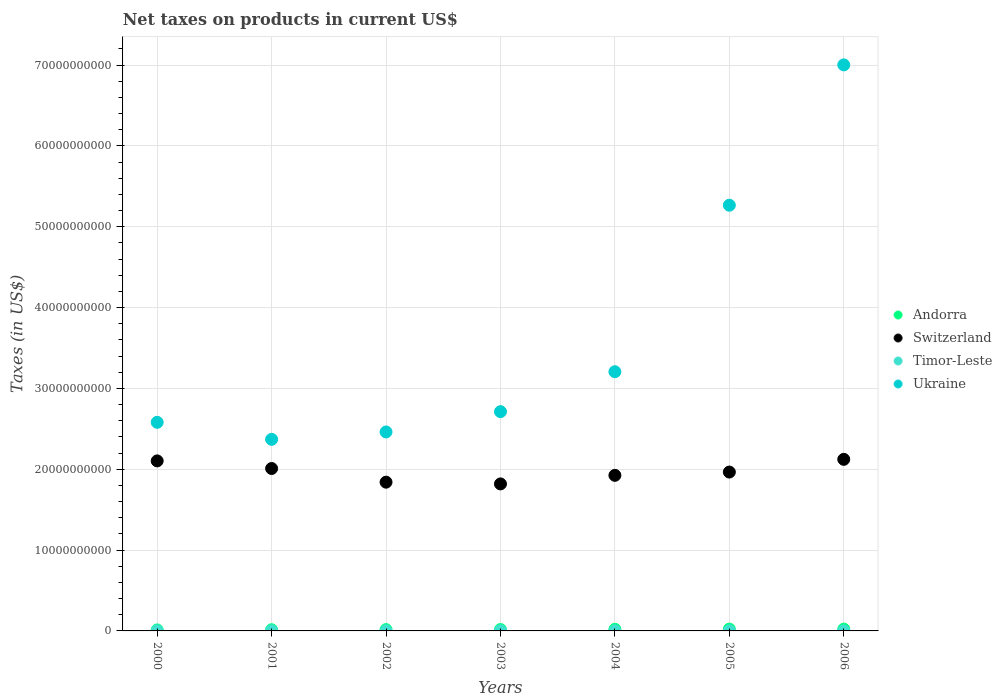How many different coloured dotlines are there?
Ensure brevity in your answer.  4. What is the net taxes on products in Ukraine in 2001?
Give a very brief answer. 2.37e+1. Across all years, what is the maximum net taxes on products in Ukraine?
Your answer should be compact. 7.00e+1. Across all years, what is the minimum net taxes on products in Switzerland?
Your answer should be compact. 1.82e+1. What is the total net taxes on products in Timor-Leste in the graph?
Provide a short and direct response. 6.80e+07. What is the difference between the net taxes on products in Ukraine in 2003 and the net taxes on products in Andorra in 2005?
Offer a very short reply. 2.69e+1. What is the average net taxes on products in Timor-Leste per year?
Offer a terse response. 9.71e+06. In the year 2002, what is the difference between the net taxes on products in Ukraine and net taxes on products in Timor-Leste?
Ensure brevity in your answer.  2.46e+1. What is the ratio of the net taxes on products in Timor-Leste in 2000 to that in 2005?
Ensure brevity in your answer.  0.42. What is the difference between the highest and the second highest net taxes on products in Switzerland?
Give a very brief answer. 1.93e+08. What is the difference between the highest and the lowest net taxes on products in Timor-Leste?
Your answer should be very brief. 1.60e+07. Is the sum of the net taxes on products in Ukraine in 2003 and 2004 greater than the maximum net taxes on products in Andorra across all years?
Make the answer very short. Yes. Is it the case that in every year, the sum of the net taxes on products in Ukraine and net taxes on products in Andorra  is greater than the sum of net taxes on products in Switzerland and net taxes on products in Timor-Leste?
Make the answer very short. Yes. Is it the case that in every year, the sum of the net taxes on products in Andorra and net taxes on products in Ukraine  is greater than the net taxes on products in Timor-Leste?
Your answer should be compact. Yes. Does the net taxes on products in Andorra monotonically increase over the years?
Offer a very short reply. No. Is the net taxes on products in Ukraine strictly greater than the net taxes on products in Switzerland over the years?
Ensure brevity in your answer.  Yes. How many dotlines are there?
Provide a succinct answer. 4. Does the graph contain any zero values?
Your answer should be very brief. Yes. Where does the legend appear in the graph?
Offer a terse response. Center right. What is the title of the graph?
Your response must be concise. Net taxes on products in current US$. Does "Switzerland" appear as one of the legend labels in the graph?
Your answer should be very brief. Yes. What is the label or title of the Y-axis?
Keep it short and to the point. Taxes (in US$). What is the Taxes (in US$) in Andorra in 2000?
Provide a succinct answer. 1.24e+08. What is the Taxes (in US$) of Switzerland in 2000?
Keep it short and to the point. 2.10e+1. What is the Taxes (in US$) in Timor-Leste in 2000?
Provide a short and direct response. 5.00e+06. What is the Taxes (in US$) of Ukraine in 2000?
Provide a succinct answer. 2.58e+1. What is the Taxes (in US$) in Andorra in 2001?
Your answer should be very brief. 1.47e+08. What is the Taxes (in US$) of Switzerland in 2001?
Give a very brief answer. 2.01e+1. What is the Taxes (in US$) in Timor-Leste in 2001?
Offer a very short reply. 8.00e+06. What is the Taxes (in US$) of Ukraine in 2001?
Offer a terse response. 2.37e+1. What is the Taxes (in US$) of Andorra in 2002?
Offer a very short reply. 1.66e+08. What is the Taxes (in US$) of Switzerland in 2002?
Ensure brevity in your answer.  1.84e+1. What is the Taxes (in US$) of Timor-Leste in 2002?
Provide a succinct answer. 1.20e+07. What is the Taxes (in US$) in Ukraine in 2002?
Your response must be concise. 2.46e+1. What is the Taxes (in US$) of Andorra in 2003?
Give a very brief answer. 1.74e+08. What is the Taxes (in US$) of Switzerland in 2003?
Your answer should be compact. 1.82e+1. What is the Taxes (in US$) of Timor-Leste in 2003?
Make the answer very short. 1.50e+07. What is the Taxes (in US$) in Ukraine in 2003?
Provide a short and direct response. 2.71e+1. What is the Taxes (in US$) in Andorra in 2004?
Your answer should be compact. 2.00e+08. What is the Taxes (in US$) in Switzerland in 2004?
Make the answer very short. 1.92e+1. What is the Taxes (in US$) of Timor-Leste in 2004?
Offer a very short reply. 1.60e+07. What is the Taxes (in US$) in Ukraine in 2004?
Make the answer very short. 3.21e+1. What is the Taxes (in US$) in Andorra in 2005?
Give a very brief answer. 2.24e+08. What is the Taxes (in US$) in Switzerland in 2005?
Offer a terse response. 1.97e+1. What is the Taxes (in US$) in Ukraine in 2005?
Provide a succinct answer. 5.27e+1. What is the Taxes (in US$) of Andorra in 2006?
Offer a very short reply. 2.23e+08. What is the Taxes (in US$) of Switzerland in 2006?
Your answer should be compact. 2.12e+1. What is the Taxes (in US$) of Ukraine in 2006?
Keep it short and to the point. 7.00e+1. Across all years, what is the maximum Taxes (in US$) of Andorra?
Offer a very short reply. 2.24e+08. Across all years, what is the maximum Taxes (in US$) in Switzerland?
Your response must be concise. 2.12e+1. Across all years, what is the maximum Taxes (in US$) in Timor-Leste?
Ensure brevity in your answer.  1.60e+07. Across all years, what is the maximum Taxes (in US$) in Ukraine?
Provide a succinct answer. 7.00e+1. Across all years, what is the minimum Taxes (in US$) of Andorra?
Provide a succinct answer. 1.24e+08. Across all years, what is the minimum Taxes (in US$) in Switzerland?
Ensure brevity in your answer.  1.82e+1. Across all years, what is the minimum Taxes (in US$) in Ukraine?
Offer a terse response. 2.37e+1. What is the total Taxes (in US$) in Andorra in the graph?
Give a very brief answer. 1.26e+09. What is the total Taxes (in US$) of Switzerland in the graph?
Offer a very short reply. 1.38e+11. What is the total Taxes (in US$) in Timor-Leste in the graph?
Provide a short and direct response. 6.80e+07. What is the total Taxes (in US$) of Ukraine in the graph?
Ensure brevity in your answer.  2.56e+11. What is the difference between the Taxes (in US$) in Andorra in 2000 and that in 2001?
Your answer should be compact. -2.25e+07. What is the difference between the Taxes (in US$) in Switzerland in 2000 and that in 2001?
Provide a short and direct response. 9.39e+08. What is the difference between the Taxes (in US$) in Timor-Leste in 2000 and that in 2001?
Offer a terse response. -3.00e+06. What is the difference between the Taxes (in US$) in Ukraine in 2000 and that in 2001?
Make the answer very short. 2.11e+09. What is the difference between the Taxes (in US$) of Andorra in 2000 and that in 2002?
Your response must be concise. -4.13e+07. What is the difference between the Taxes (in US$) of Switzerland in 2000 and that in 2002?
Provide a short and direct response. 2.63e+09. What is the difference between the Taxes (in US$) of Timor-Leste in 2000 and that in 2002?
Offer a very short reply. -7.00e+06. What is the difference between the Taxes (in US$) in Ukraine in 2000 and that in 2002?
Offer a terse response. 1.19e+09. What is the difference between the Taxes (in US$) of Andorra in 2000 and that in 2003?
Keep it short and to the point. -4.95e+07. What is the difference between the Taxes (in US$) in Switzerland in 2000 and that in 2003?
Ensure brevity in your answer.  2.85e+09. What is the difference between the Taxes (in US$) of Timor-Leste in 2000 and that in 2003?
Offer a terse response. -1.00e+07. What is the difference between the Taxes (in US$) in Ukraine in 2000 and that in 2003?
Your response must be concise. -1.32e+09. What is the difference between the Taxes (in US$) in Andorra in 2000 and that in 2004?
Keep it short and to the point. -7.55e+07. What is the difference between the Taxes (in US$) of Switzerland in 2000 and that in 2004?
Provide a short and direct response. 1.79e+09. What is the difference between the Taxes (in US$) of Timor-Leste in 2000 and that in 2004?
Your answer should be compact. -1.10e+07. What is the difference between the Taxes (in US$) of Ukraine in 2000 and that in 2004?
Keep it short and to the point. -6.26e+09. What is the difference between the Taxes (in US$) in Andorra in 2000 and that in 2005?
Ensure brevity in your answer.  -9.97e+07. What is the difference between the Taxes (in US$) of Switzerland in 2000 and that in 2005?
Provide a succinct answer. 1.38e+09. What is the difference between the Taxes (in US$) in Timor-Leste in 2000 and that in 2005?
Give a very brief answer. -7.00e+06. What is the difference between the Taxes (in US$) of Ukraine in 2000 and that in 2005?
Provide a short and direct response. -2.69e+1. What is the difference between the Taxes (in US$) of Andorra in 2000 and that in 2006?
Your answer should be compact. -9.82e+07. What is the difference between the Taxes (in US$) of Switzerland in 2000 and that in 2006?
Your answer should be compact. -1.93e+08. What is the difference between the Taxes (in US$) of Ukraine in 2000 and that in 2006?
Keep it short and to the point. -4.42e+1. What is the difference between the Taxes (in US$) in Andorra in 2001 and that in 2002?
Keep it short and to the point. -1.88e+07. What is the difference between the Taxes (in US$) of Switzerland in 2001 and that in 2002?
Your response must be concise. 1.69e+09. What is the difference between the Taxes (in US$) of Ukraine in 2001 and that in 2002?
Offer a terse response. -9.16e+08. What is the difference between the Taxes (in US$) of Andorra in 2001 and that in 2003?
Your response must be concise. -2.70e+07. What is the difference between the Taxes (in US$) in Switzerland in 2001 and that in 2003?
Offer a very short reply. 1.91e+09. What is the difference between the Taxes (in US$) in Timor-Leste in 2001 and that in 2003?
Provide a short and direct response. -7.00e+06. What is the difference between the Taxes (in US$) of Ukraine in 2001 and that in 2003?
Your response must be concise. -3.43e+09. What is the difference between the Taxes (in US$) of Andorra in 2001 and that in 2004?
Keep it short and to the point. -5.30e+07. What is the difference between the Taxes (in US$) in Switzerland in 2001 and that in 2004?
Offer a terse response. 8.47e+08. What is the difference between the Taxes (in US$) of Timor-Leste in 2001 and that in 2004?
Your answer should be compact. -8.00e+06. What is the difference between the Taxes (in US$) in Ukraine in 2001 and that in 2004?
Keep it short and to the point. -8.37e+09. What is the difference between the Taxes (in US$) of Andorra in 2001 and that in 2005?
Your answer should be very brief. -7.72e+07. What is the difference between the Taxes (in US$) of Switzerland in 2001 and that in 2005?
Offer a very short reply. 4.40e+08. What is the difference between the Taxes (in US$) of Ukraine in 2001 and that in 2005?
Your answer should be compact. -2.90e+1. What is the difference between the Taxes (in US$) of Andorra in 2001 and that in 2006?
Your answer should be compact. -7.58e+07. What is the difference between the Taxes (in US$) of Switzerland in 2001 and that in 2006?
Your answer should be compact. -1.13e+09. What is the difference between the Taxes (in US$) of Ukraine in 2001 and that in 2006?
Offer a terse response. -4.63e+1. What is the difference between the Taxes (in US$) in Andorra in 2002 and that in 2003?
Ensure brevity in your answer.  -8.15e+06. What is the difference between the Taxes (in US$) in Switzerland in 2002 and that in 2003?
Make the answer very short. 2.15e+08. What is the difference between the Taxes (in US$) of Timor-Leste in 2002 and that in 2003?
Provide a short and direct response. -3.00e+06. What is the difference between the Taxes (in US$) in Ukraine in 2002 and that in 2003?
Ensure brevity in your answer.  -2.51e+09. What is the difference between the Taxes (in US$) of Andorra in 2002 and that in 2004?
Ensure brevity in your answer.  -3.42e+07. What is the difference between the Taxes (in US$) in Switzerland in 2002 and that in 2004?
Your answer should be very brief. -8.44e+08. What is the difference between the Taxes (in US$) of Timor-Leste in 2002 and that in 2004?
Provide a short and direct response. -4.00e+06. What is the difference between the Taxes (in US$) in Ukraine in 2002 and that in 2004?
Your response must be concise. -7.45e+09. What is the difference between the Taxes (in US$) of Andorra in 2002 and that in 2005?
Your answer should be very brief. -5.84e+07. What is the difference between the Taxes (in US$) in Switzerland in 2002 and that in 2005?
Provide a succinct answer. -1.25e+09. What is the difference between the Taxes (in US$) in Ukraine in 2002 and that in 2005?
Give a very brief answer. -2.81e+1. What is the difference between the Taxes (in US$) of Andorra in 2002 and that in 2006?
Offer a terse response. -5.69e+07. What is the difference between the Taxes (in US$) of Switzerland in 2002 and that in 2006?
Ensure brevity in your answer.  -2.82e+09. What is the difference between the Taxes (in US$) of Ukraine in 2002 and that in 2006?
Your answer should be compact. -4.54e+1. What is the difference between the Taxes (in US$) in Andorra in 2003 and that in 2004?
Ensure brevity in your answer.  -2.60e+07. What is the difference between the Taxes (in US$) in Switzerland in 2003 and that in 2004?
Your response must be concise. -1.06e+09. What is the difference between the Taxes (in US$) in Ukraine in 2003 and that in 2004?
Give a very brief answer. -4.94e+09. What is the difference between the Taxes (in US$) of Andorra in 2003 and that in 2005?
Provide a short and direct response. -5.02e+07. What is the difference between the Taxes (in US$) of Switzerland in 2003 and that in 2005?
Your answer should be very brief. -1.47e+09. What is the difference between the Taxes (in US$) in Timor-Leste in 2003 and that in 2005?
Provide a succinct answer. 3.00e+06. What is the difference between the Taxes (in US$) in Ukraine in 2003 and that in 2005?
Make the answer very short. -2.55e+1. What is the difference between the Taxes (in US$) in Andorra in 2003 and that in 2006?
Keep it short and to the point. -4.88e+07. What is the difference between the Taxes (in US$) in Switzerland in 2003 and that in 2006?
Your response must be concise. -3.04e+09. What is the difference between the Taxes (in US$) in Ukraine in 2003 and that in 2006?
Your answer should be compact. -4.29e+1. What is the difference between the Taxes (in US$) in Andorra in 2004 and that in 2005?
Your answer should be compact. -2.42e+07. What is the difference between the Taxes (in US$) in Switzerland in 2004 and that in 2005?
Provide a succinct answer. -4.07e+08. What is the difference between the Taxes (in US$) in Timor-Leste in 2004 and that in 2005?
Offer a very short reply. 4.00e+06. What is the difference between the Taxes (in US$) of Ukraine in 2004 and that in 2005?
Offer a very short reply. -2.06e+1. What is the difference between the Taxes (in US$) of Andorra in 2004 and that in 2006?
Offer a terse response. -2.28e+07. What is the difference between the Taxes (in US$) of Switzerland in 2004 and that in 2006?
Offer a terse response. -1.98e+09. What is the difference between the Taxes (in US$) of Ukraine in 2004 and that in 2006?
Ensure brevity in your answer.  -3.80e+1. What is the difference between the Taxes (in US$) in Andorra in 2005 and that in 2006?
Offer a very short reply. 1.46e+06. What is the difference between the Taxes (in US$) in Switzerland in 2005 and that in 2006?
Your answer should be compact. -1.57e+09. What is the difference between the Taxes (in US$) of Ukraine in 2005 and that in 2006?
Ensure brevity in your answer.  -1.74e+1. What is the difference between the Taxes (in US$) of Andorra in 2000 and the Taxes (in US$) of Switzerland in 2001?
Ensure brevity in your answer.  -2.00e+1. What is the difference between the Taxes (in US$) in Andorra in 2000 and the Taxes (in US$) in Timor-Leste in 2001?
Provide a succinct answer. 1.16e+08. What is the difference between the Taxes (in US$) in Andorra in 2000 and the Taxes (in US$) in Ukraine in 2001?
Your answer should be very brief. -2.36e+1. What is the difference between the Taxes (in US$) in Switzerland in 2000 and the Taxes (in US$) in Timor-Leste in 2001?
Keep it short and to the point. 2.10e+1. What is the difference between the Taxes (in US$) of Switzerland in 2000 and the Taxes (in US$) of Ukraine in 2001?
Your answer should be compact. -2.67e+09. What is the difference between the Taxes (in US$) of Timor-Leste in 2000 and the Taxes (in US$) of Ukraine in 2001?
Ensure brevity in your answer.  -2.37e+1. What is the difference between the Taxes (in US$) in Andorra in 2000 and the Taxes (in US$) in Switzerland in 2002?
Your response must be concise. -1.83e+1. What is the difference between the Taxes (in US$) in Andorra in 2000 and the Taxes (in US$) in Timor-Leste in 2002?
Make the answer very short. 1.12e+08. What is the difference between the Taxes (in US$) in Andorra in 2000 and the Taxes (in US$) in Ukraine in 2002?
Offer a very short reply. -2.45e+1. What is the difference between the Taxes (in US$) in Switzerland in 2000 and the Taxes (in US$) in Timor-Leste in 2002?
Your answer should be compact. 2.10e+1. What is the difference between the Taxes (in US$) in Switzerland in 2000 and the Taxes (in US$) in Ukraine in 2002?
Offer a very short reply. -3.58e+09. What is the difference between the Taxes (in US$) in Timor-Leste in 2000 and the Taxes (in US$) in Ukraine in 2002?
Make the answer very short. -2.46e+1. What is the difference between the Taxes (in US$) in Andorra in 2000 and the Taxes (in US$) in Switzerland in 2003?
Your answer should be very brief. -1.81e+1. What is the difference between the Taxes (in US$) in Andorra in 2000 and the Taxes (in US$) in Timor-Leste in 2003?
Offer a terse response. 1.09e+08. What is the difference between the Taxes (in US$) of Andorra in 2000 and the Taxes (in US$) of Ukraine in 2003?
Keep it short and to the point. -2.70e+1. What is the difference between the Taxes (in US$) of Switzerland in 2000 and the Taxes (in US$) of Timor-Leste in 2003?
Keep it short and to the point. 2.10e+1. What is the difference between the Taxes (in US$) in Switzerland in 2000 and the Taxes (in US$) in Ukraine in 2003?
Your response must be concise. -6.09e+09. What is the difference between the Taxes (in US$) in Timor-Leste in 2000 and the Taxes (in US$) in Ukraine in 2003?
Your answer should be very brief. -2.71e+1. What is the difference between the Taxes (in US$) in Andorra in 2000 and the Taxes (in US$) in Switzerland in 2004?
Your response must be concise. -1.91e+1. What is the difference between the Taxes (in US$) in Andorra in 2000 and the Taxes (in US$) in Timor-Leste in 2004?
Your answer should be compact. 1.08e+08. What is the difference between the Taxes (in US$) of Andorra in 2000 and the Taxes (in US$) of Ukraine in 2004?
Provide a succinct answer. -3.19e+1. What is the difference between the Taxes (in US$) in Switzerland in 2000 and the Taxes (in US$) in Timor-Leste in 2004?
Offer a terse response. 2.10e+1. What is the difference between the Taxes (in US$) of Switzerland in 2000 and the Taxes (in US$) of Ukraine in 2004?
Your response must be concise. -1.10e+1. What is the difference between the Taxes (in US$) in Timor-Leste in 2000 and the Taxes (in US$) in Ukraine in 2004?
Offer a terse response. -3.21e+1. What is the difference between the Taxes (in US$) in Andorra in 2000 and the Taxes (in US$) in Switzerland in 2005?
Your response must be concise. -1.95e+1. What is the difference between the Taxes (in US$) of Andorra in 2000 and the Taxes (in US$) of Timor-Leste in 2005?
Ensure brevity in your answer.  1.12e+08. What is the difference between the Taxes (in US$) of Andorra in 2000 and the Taxes (in US$) of Ukraine in 2005?
Your response must be concise. -5.25e+1. What is the difference between the Taxes (in US$) in Switzerland in 2000 and the Taxes (in US$) in Timor-Leste in 2005?
Your response must be concise. 2.10e+1. What is the difference between the Taxes (in US$) in Switzerland in 2000 and the Taxes (in US$) in Ukraine in 2005?
Offer a very short reply. -3.16e+1. What is the difference between the Taxes (in US$) of Timor-Leste in 2000 and the Taxes (in US$) of Ukraine in 2005?
Ensure brevity in your answer.  -5.27e+1. What is the difference between the Taxes (in US$) in Andorra in 2000 and the Taxes (in US$) in Switzerland in 2006?
Give a very brief answer. -2.11e+1. What is the difference between the Taxes (in US$) in Andorra in 2000 and the Taxes (in US$) in Ukraine in 2006?
Offer a terse response. -6.99e+1. What is the difference between the Taxes (in US$) in Switzerland in 2000 and the Taxes (in US$) in Ukraine in 2006?
Offer a very short reply. -4.90e+1. What is the difference between the Taxes (in US$) of Timor-Leste in 2000 and the Taxes (in US$) of Ukraine in 2006?
Your answer should be compact. -7.00e+1. What is the difference between the Taxes (in US$) in Andorra in 2001 and the Taxes (in US$) in Switzerland in 2002?
Your answer should be very brief. -1.83e+1. What is the difference between the Taxes (in US$) in Andorra in 2001 and the Taxes (in US$) in Timor-Leste in 2002?
Provide a short and direct response. 1.35e+08. What is the difference between the Taxes (in US$) in Andorra in 2001 and the Taxes (in US$) in Ukraine in 2002?
Ensure brevity in your answer.  -2.45e+1. What is the difference between the Taxes (in US$) in Switzerland in 2001 and the Taxes (in US$) in Timor-Leste in 2002?
Provide a short and direct response. 2.01e+1. What is the difference between the Taxes (in US$) of Switzerland in 2001 and the Taxes (in US$) of Ukraine in 2002?
Make the answer very short. -4.52e+09. What is the difference between the Taxes (in US$) in Timor-Leste in 2001 and the Taxes (in US$) in Ukraine in 2002?
Keep it short and to the point. -2.46e+1. What is the difference between the Taxes (in US$) of Andorra in 2001 and the Taxes (in US$) of Switzerland in 2003?
Offer a terse response. -1.80e+1. What is the difference between the Taxes (in US$) in Andorra in 2001 and the Taxes (in US$) in Timor-Leste in 2003?
Provide a succinct answer. 1.32e+08. What is the difference between the Taxes (in US$) of Andorra in 2001 and the Taxes (in US$) of Ukraine in 2003?
Give a very brief answer. -2.70e+1. What is the difference between the Taxes (in US$) of Switzerland in 2001 and the Taxes (in US$) of Timor-Leste in 2003?
Offer a terse response. 2.01e+1. What is the difference between the Taxes (in US$) of Switzerland in 2001 and the Taxes (in US$) of Ukraine in 2003?
Offer a terse response. -7.03e+09. What is the difference between the Taxes (in US$) of Timor-Leste in 2001 and the Taxes (in US$) of Ukraine in 2003?
Your answer should be very brief. -2.71e+1. What is the difference between the Taxes (in US$) in Andorra in 2001 and the Taxes (in US$) in Switzerland in 2004?
Offer a terse response. -1.91e+1. What is the difference between the Taxes (in US$) of Andorra in 2001 and the Taxes (in US$) of Timor-Leste in 2004?
Give a very brief answer. 1.31e+08. What is the difference between the Taxes (in US$) in Andorra in 2001 and the Taxes (in US$) in Ukraine in 2004?
Offer a terse response. -3.19e+1. What is the difference between the Taxes (in US$) in Switzerland in 2001 and the Taxes (in US$) in Timor-Leste in 2004?
Offer a terse response. 2.01e+1. What is the difference between the Taxes (in US$) in Switzerland in 2001 and the Taxes (in US$) in Ukraine in 2004?
Ensure brevity in your answer.  -1.20e+1. What is the difference between the Taxes (in US$) in Timor-Leste in 2001 and the Taxes (in US$) in Ukraine in 2004?
Provide a short and direct response. -3.21e+1. What is the difference between the Taxes (in US$) of Andorra in 2001 and the Taxes (in US$) of Switzerland in 2005?
Your answer should be compact. -1.95e+1. What is the difference between the Taxes (in US$) of Andorra in 2001 and the Taxes (in US$) of Timor-Leste in 2005?
Keep it short and to the point. 1.35e+08. What is the difference between the Taxes (in US$) in Andorra in 2001 and the Taxes (in US$) in Ukraine in 2005?
Provide a short and direct response. -5.25e+1. What is the difference between the Taxes (in US$) in Switzerland in 2001 and the Taxes (in US$) in Timor-Leste in 2005?
Give a very brief answer. 2.01e+1. What is the difference between the Taxes (in US$) of Switzerland in 2001 and the Taxes (in US$) of Ukraine in 2005?
Your answer should be compact. -3.26e+1. What is the difference between the Taxes (in US$) in Timor-Leste in 2001 and the Taxes (in US$) in Ukraine in 2005?
Ensure brevity in your answer.  -5.27e+1. What is the difference between the Taxes (in US$) in Andorra in 2001 and the Taxes (in US$) in Switzerland in 2006?
Give a very brief answer. -2.11e+1. What is the difference between the Taxes (in US$) in Andorra in 2001 and the Taxes (in US$) in Ukraine in 2006?
Offer a very short reply. -6.99e+1. What is the difference between the Taxes (in US$) of Switzerland in 2001 and the Taxes (in US$) of Ukraine in 2006?
Provide a short and direct response. -4.99e+1. What is the difference between the Taxes (in US$) of Timor-Leste in 2001 and the Taxes (in US$) of Ukraine in 2006?
Give a very brief answer. -7.00e+1. What is the difference between the Taxes (in US$) of Andorra in 2002 and the Taxes (in US$) of Switzerland in 2003?
Your response must be concise. -1.80e+1. What is the difference between the Taxes (in US$) in Andorra in 2002 and the Taxes (in US$) in Timor-Leste in 2003?
Give a very brief answer. 1.51e+08. What is the difference between the Taxes (in US$) of Andorra in 2002 and the Taxes (in US$) of Ukraine in 2003?
Your response must be concise. -2.70e+1. What is the difference between the Taxes (in US$) of Switzerland in 2002 and the Taxes (in US$) of Timor-Leste in 2003?
Keep it short and to the point. 1.84e+1. What is the difference between the Taxes (in US$) in Switzerland in 2002 and the Taxes (in US$) in Ukraine in 2003?
Make the answer very short. -8.72e+09. What is the difference between the Taxes (in US$) of Timor-Leste in 2002 and the Taxes (in US$) of Ukraine in 2003?
Offer a very short reply. -2.71e+1. What is the difference between the Taxes (in US$) in Andorra in 2002 and the Taxes (in US$) in Switzerland in 2004?
Keep it short and to the point. -1.91e+1. What is the difference between the Taxes (in US$) in Andorra in 2002 and the Taxes (in US$) in Timor-Leste in 2004?
Offer a very short reply. 1.50e+08. What is the difference between the Taxes (in US$) in Andorra in 2002 and the Taxes (in US$) in Ukraine in 2004?
Your answer should be compact. -3.19e+1. What is the difference between the Taxes (in US$) of Switzerland in 2002 and the Taxes (in US$) of Timor-Leste in 2004?
Your answer should be compact. 1.84e+1. What is the difference between the Taxes (in US$) of Switzerland in 2002 and the Taxes (in US$) of Ukraine in 2004?
Your response must be concise. -1.37e+1. What is the difference between the Taxes (in US$) in Timor-Leste in 2002 and the Taxes (in US$) in Ukraine in 2004?
Your answer should be compact. -3.21e+1. What is the difference between the Taxes (in US$) in Andorra in 2002 and the Taxes (in US$) in Switzerland in 2005?
Provide a succinct answer. -1.95e+1. What is the difference between the Taxes (in US$) in Andorra in 2002 and the Taxes (in US$) in Timor-Leste in 2005?
Keep it short and to the point. 1.54e+08. What is the difference between the Taxes (in US$) of Andorra in 2002 and the Taxes (in US$) of Ukraine in 2005?
Make the answer very short. -5.25e+1. What is the difference between the Taxes (in US$) of Switzerland in 2002 and the Taxes (in US$) of Timor-Leste in 2005?
Provide a short and direct response. 1.84e+1. What is the difference between the Taxes (in US$) in Switzerland in 2002 and the Taxes (in US$) in Ukraine in 2005?
Offer a very short reply. -3.43e+1. What is the difference between the Taxes (in US$) of Timor-Leste in 2002 and the Taxes (in US$) of Ukraine in 2005?
Ensure brevity in your answer.  -5.27e+1. What is the difference between the Taxes (in US$) of Andorra in 2002 and the Taxes (in US$) of Switzerland in 2006?
Offer a very short reply. -2.11e+1. What is the difference between the Taxes (in US$) in Andorra in 2002 and the Taxes (in US$) in Ukraine in 2006?
Your answer should be compact. -6.99e+1. What is the difference between the Taxes (in US$) of Switzerland in 2002 and the Taxes (in US$) of Ukraine in 2006?
Give a very brief answer. -5.16e+1. What is the difference between the Taxes (in US$) in Timor-Leste in 2002 and the Taxes (in US$) in Ukraine in 2006?
Provide a short and direct response. -7.00e+1. What is the difference between the Taxes (in US$) in Andorra in 2003 and the Taxes (in US$) in Switzerland in 2004?
Ensure brevity in your answer.  -1.91e+1. What is the difference between the Taxes (in US$) in Andorra in 2003 and the Taxes (in US$) in Timor-Leste in 2004?
Your answer should be very brief. 1.58e+08. What is the difference between the Taxes (in US$) in Andorra in 2003 and the Taxes (in US$) in Ukraine in 2004?
Offer a terse response. -3.19e+1. What is the difference between the Taxes (in US$) in Switzerland in 2003 and the Taxes (in US$) in Timor-Leste in 2004?
Provide a short and direct response. 1.82e+1. What is the difference between the Taxes (in US$) of Switzerland in 2003 and the Taxes (in US$) of Ukraine in 2004?
Your answer should be compact. -1.39e+1. What is the difference between the Taxes (in US$) in Timor-Leste in 2003 and the Taxes (in US$) in Ukraine in 2004?
Offer a very short reply. -3.21e+1. What is the difference between the Taxes (in US$) of Andorra in 2003 and the Taxes (in US$) of Switzerland in 2005?
Provide a short and direct response. -1.95e+1. What is the difference between the Taxes (in US$) in Andorra in 2003 and the Taxes (in US$) in Timor-Leste in 2005?
Give a very brief answer. 1.62e+08. What is the difference between the Taxes (in US$) of Andorra in 2003 and the Taxes (in US$) of Ukraine in 2005?
Offer a terse response. -5.25e+1. What is the difference between the Taxes (in US$) of Switzerland in 2003 and the Taxes (in US$) of Timor-Leste in 2005?
Offer a terse response. 1.82e+1. What is the difference between the Taxes (in US$) of Switzerland in 2003 and the Taxes (in US$) of Ukraine in 2005?
Provide a succinct answer. -3.45e+1. What is the difference between the Taxes (in US$) in Timor-Leste in 2003 and the Taxes (in US$) in Ukraine in 2005?
Offer a terse response. -5.27e+1. What is the difference between the Taxes (in US$) of Andorra in 2003 and the Taxes (in US$) of Switzerland in 2006?
Your answer should be compact. -2.11e+1. What is the difference between the Taxes (in US$) in Andorra in 2003 and the Taxes (in US$) in Ukraine in 2006?
Give a very brief answer. -6.99e+1. What is the difference between the Taxes (in US$) of Switzerland in 2003 and the Taxes (in US$) of Ukraine in 2006?
Make the answer very short. -5.18e+1. What is the difference between the Taxes (in US$) of Timor-Leste in 2003 and the Taxes (in US$) of Ukraine in 2006?
Your answer should be compact. -7.00e+1. What is the difference between the Taxes (in US$) in Andorra in 2004 and the Taxes (in US$) in Switzerland in 2005?
Your response must be concise. -1.95e+1. What is the difference between the Taxes (in US$) of Andorra in 2004 and the Taxes (in US$) of Timor-Leste in 2005?
Keep it short and to the point. 1.88e+08. What is the difference between the Taxes (in US$) of Andorra in 2004 and the Taxes (in US$) of Ukraine in 2005?
Provide a short and direct response. -5.25e+1. What is the difference between the Taxes (in US$) in Switzerland in 2004 and the Taxes (in US$) in Timor-Leste in 2005?
Your response must be concise. 1.92e+1. What is the difference between the Taxes (in US$) in Switzerland in 2004 and the Taxes (in US$) in Ukraine in 2005?
Provide a short and direct response. -3.34e+1. What is the difference between the Taxes (in US$) in Timor-Leste in 2004 and the Taxes (in US$) in Ukraine in 2005?
Keep it short and to the point. -5.27e+1. What is the difference between the Taxes (in US$) of Andorra in 2004 and the Taxes (in US$) of Switzerland in 2006?
Give a very brief answer. -2.10e+1. What is the difference between the Taxes (in US$) in Andorra in 2004 and the Taxes (in US$) in Ukraine in 2006?
Provide a short and direct response. -6.98e+1. What is the difference between the Taxes (in US$) in Switzerland in 2004 and the Taxes (in US$) in Ukraine in 2006?
Make the answer very short. -5.08e+1. What is the difference between the Taxes (in US$) of Timor-Leste in 2004 and the Taxes (in US$) of Ukraine in 2006?
Provide a short and direct response. -7.00e+1. What is the difference between the Taxes (in US$) in Andorra in 2005 and the Taxes (in US$) in Switzerland in 2006?
Provide a succinct answer. -2.10e+1. What is the difference between the Taxes (in US$) of Andorra in 2005 and the Taxes (in US$) of Ukraine in 2006?
Your answer should be compact. -6.98e+1. What is the difference between the Taxes (in US$) of Switzerland in 2005 and the Taxes (in US$) of Ukraine in 2006?
Give a very brief answer. -5.04e+1. What is the difference between the Taxes (in US$) of Timor-Leste in 2005 and the Taxes (in US$) of Ukraine in 2006?
Make the answer very short. -7.00e+1. What is the average Taxes (in US$) in Andorra per year?
Offer a very short reply. 1.80e+08. What is the average Taxes (in US$) in Switzerland per year?
Ensure brevity in your answer.  1.97e+1. What is the average Taxes (in US$) in Timor-Leste per year?
Provide a short and direct response. 9.71e+06. What is the average Taxes (in US$) of Ukraine per year?
Your response must be concise. 3.66e+1. In the year 2000, what is the difference between the Taxes (in US$) of Andorra and Taxes (in US$) of Switzerland?
Your answer should be very brief. -2.09e+1. In the year 2000, what is the difference between the Taxes (in US$) of Andorra and Taxes (in US$) of Timor-Leste?
Your answer should be very brief. 1.19e+08. In the year 2000, what is the difference between the Taxes (in US$) in Andorra and Taxes (in US$) in Ukraine?
Keep it short and to the point. -2.57e+1. In the year 2000, what is the difference between the Taxes (in US$) in Switzerland and Taxes (in US$) in Timor-Leste?
Your response must be concise. 2.10e+1. In the year 2000, what is the difference between the Taxes (in US$) of Switzerland and Taxes (in US$) of Ukraine?
Your answer should be very brief. -4.77e+09. In the year 2000, what is the difference between the Taxes (in US$) in Timor-Leste and Taxes (in US$) in Ukraine?
Your response must be concise. -2.58e+1. In the year 2001, what is the difference between the Taxes (in US$) of Andorra and Taxes (in US$) of Switzerland?
Provide a short and direct response. -1.99e+1. In the year 2001, what is the difference between the Taxes (in US$) of Andorra and Taxes (in US$) of Timor-Leste?
Your answer should be very brief. 1.39e+08. In the year 2001, what is the difference between the Taxes (in US$) of Andorra and Taxes (in US$) of Ukraine?
Your answer should be very brief. -2.36e+1. In the year 2001, what is the difference between the Taxes (in US$) in Switzerland and Taxes (in US$) in Timor-Leste?
Your answer should be very brief. 2.01e+1. In the year 2001, what is the difference between the Taxes (in US$) of Switzerland and Taxes (in US$) of Ukraine?
Your response must be concise. -3.61e+09. In the year 2001, what is the difference between the Taxes (in US$) in Timor-Leste and Taxes (in US$) in Ukraine?
Offer a very short reply. -2.37e+1. In the year 2002, what is the difference between the Taxes (in US$) of Andorra and Taxes (in US$) of Switzerland?
Offer a terse response. -1.82e+1. In the year 2002, what is the difference between the Taxes (in US$) of Andorra and Taxes (in US$) of Timor-Leste?
Provide a short and direct response. 1.54e+08. In the year 2002, what is the difference between the Taxes (in US$) in Andorra and Taxes (in US$) in Ukraine?
Your response must be concise. -2.45e+1. In the year 2002, what is the difference between the Taxes (in US$) of Switzerland and Taxes (in US$) of Timor-Leste?
Your response must be concise. 1.84e+1. In the year 2002, what is the difference between the Taxes (in US$) in Switzerland and Taxes (in US$) in Ukraine?
Ensure brevity in your answer.  -6.21e+09. In the year 2002, what is the difference between the Taxes (in US$) in Timor-Leste and Taxes (in US$) in Ukraine?
Provide a succinct answer. -2.46e+1. In the year 2003, what is the difference between the Taxes (in US$) of Andorra and Taxes (in US$) of Switzerland?
Make the answer very short. -1.80e+1. In the year 2003, what is the difference between the Taxes (in US$) of Andorra and Taxes (in US$) of Timor-Leste?
Offer a very short reply. 1.59e+08. In the year 2003, what is the difference between the Taxes (in US$) of Andorra and Taxes (in US$) of Ukraine?
Your answer should be compact. -2.70e+1. In the year 2003, what is the difference between the Taxes (in US$) of Switzerland and Taxes (in US$) of Timor-Leste?
Ensure brevity in your answer.  1.82e+1. In the year 2003, what is the difference between the Taxes (in US$) of Switzerland and Taxes (in US$) of Ukraine?
Offer a terse response. -8.94e+09. In the year 2003, what is the difference between the Taxes (in US$) of Timor-Leste and Taxes (in US$) of Ukraine?
Offer a very short reply. -2.71e+1. In the year 2004, what is the difference between the Taxes (in US$) in Andorra and Taxes (in US$) in Switzerland?
Ensure brevity in your answer.  -1.90e+1. In the year 2004, what is the difference between the Taxes (in US$) of Andorra and Taxes (in US$) of Timor-Leste?
Your answer should be compact. 1.84e+08. In the year 2004, what is the difference between the Taxes (in US$) of Andorra and Taxes (in US$) of Ukraine?
Provide a short and direct response. -3.19e+1. In the year 2004, what is the difference between the Taxes (in US$) in Switzerland and Taxes (in US$) in Timor-Leste?
Keep it short and to the point. 1.92e+1. In the year 2004, what is the difference between the Taxes (in US$) of Switzerland and Taxes (in US$) of Ukraine?
Provide a short and direct response. -1.28e+1. In the year 2004, what is the difference between the Taxes (in US$) in Timor-Leste and Taxes (in US$) in Ukraine?
Offer a very short reply. -3.21e+1. In the year 2005, what is the difference between the Taxes (in US$) of Andorra and Taxes (in US$) of Switzerland?
Ensure brevity in your answer.  -1.94e+1. In the year 2005, what is the difference between the Taxes (in US$) of Andorra and Taxes (in US$) of Timor-Leste?
Your answer should be very brief. 2.12e+08. In the year 2005, what is the difference between the Taxes (in US$) of Andorra and Taxes (in US$) of Ukraine?
Provide a short and direct response. -5.24e+1. In the year 2005, what is the difference between the Taxes (in US$) in Switzerland and Taxes (in US$) in Timor-Leste?
Offer a very short reply. 1.96e+1. In the year 2005, what is the difference between the Taxes (in US$) of Switzerland and Taxes (in US$) of Ukraine?
Provide a short and direct response. -3.30e+1. In the year 2005, what is the difference between the Taxes (in US$) of Timor-Leste and Taxes (in US$) of Ukraine?
Offer a very short reply. -5.27e+1. In the year 2006, what is the difference between the Taxes (in US$) in Andorra and Taxes (in US$) in Switzerland?
Your response must be concise. -2.10e+1. In the year 2006, what is the difference between the Taxes (in US$) of Andorra and Taxes (in US$) of Ukraine?
Provide a succinct answer. -6.98e+1. In the year 2006, what is the difference between the Taxes (in US$) in Switzerland and Taxes (in US$) in Ukraine?
Your response must be concise. -4.88e+1. What is the ratio of the Taxes (in US$) in Andorra in 2000 to that in 2001?
Provide a succinct answer. 0.85. What is the ratio of the Taxes (in US$) in Switzerland in 2000 to that in 2001?
Your answer should be very brief. 1.05. What is the ratio of the Taxes (in US$) of Ukraine in 2000 to that in 2001?
Keep it short and to the point. 1.09. What is the ratio of the Taxes (in US$) of Andorra in 2000 to that in 2002?
Your response must be concise. 0.75. What is the ratio of the Taxes (in US$) in Switzerland in 2000 to that in 2002?
Your answer should be compact. 1.14. What is the ratio of the Taxes (in US$) in Timor-Leste in 2000 to that in 2002?
Provide a succinct answer. 0.42. What is the ratio of the Taxes (in US$) in Ukraine in 2000 to that in 2002?
Provide a short and direct response. 1.05. What is the ratio of the Taxes (in US$) of Andorra in 2000 to that in 2003?
Your answer should be very brief. 0.72. What is the ratio of the Taxes (in US$) in Switzerland in 2000 to that in 2003?
Offer a terse response. 1.16. What is the ratio of the Taxes (in US$) of Timor-Leste in 2000 to that in 2003?
Your answer should be compact. 0.33. What is the ratio of the Taxes (in US$) of Ukraine in 2000 to that in 2003?
Offer a terse response. 0.95. What is the ratio of the Taxes (in US$) in Andorra in 2000 to that in 2004?
Your answer should be very brief. 0.62. What is the ratio of the Taxes (in US$) of Switzerland in 2000 to that in 2004?
Your response must be concise. 1.09. What is the ratio of the Taxes (in US$) of Timor-Leste in 2000 to that in 2004?
Provide a succinct answer. 0.31. What is the ratio of the Taxes (in US$) of Ukraine in 2000 to that in 2004?
Make the answer very short. 0.8. What is the ratio of the Taxes (in US$) in Andorra in 2000 to that in 2005?
Your response must be concise. 0.55. What is the ratio of the Taxes (in US$) in Switzerland in 2000 to that in 2005?
Make the answer very short. 1.07. What is the ratio of the Taxes (in US$) of Timor-Leste in 2000 to that in 2005?
Ensure brevity in your answer.  0.42. What is the ratio of the Taxes (in US$) in Ukraine in 2000 to that in 2005?
Ensure brevity in your answer.  0.49. What is the ratio of the Taxes (in US$) in Andorra in 2000 to that in 2006?
Your response must be concise. 0.56. What is the ratio of the Taxes (in US$) in Switzerland in 2000 to that in 2006?
Provide a short and direct response. 0.99. What is the ratio of the Taxes (in US$) of Ukraine in 2000 to that in 2006?
Offer a terse response. 0.37. What is the ratio of the Taxes (in US$) of Andorra in 2001 to that in 2002?
Keep it short and to the point. 0.89. What is the ratio of the Taxes (in US$) in Switzerland in 2001 to that in 2002?
Ensure brevity in your answer.  1.09. What is the ratio of the Taxes (in US$) in Ukraine in 2001 to that in 2002?
Provide a short and direct response. 0.96. What is the ratio of the Taxes (in US$) in Andorra in 2001 to that in 2003?
Make the answer very short. 0.84. What is the ratio of the Taxes (in US$) of Switzerland in 2001 to that in 2003?
Your answer should be compact. 1.1. What is the ratio of the Taxes (in US$) of Timor-Leste in 2001 to that in 2003?
Offer a very short reply. 0.53. What is the ratio of the Taxes (in US$) in Ukraine in 2001 to that in 2003?
Offer a terse response. 0.87. What is the ratio of the Taxes (in US$) of Andorra in 2001 to that in 2004?
Provide a short and direct response. 0.73. What is the ratio of the Taxes (in US$) in Switzerland in 2001 to that in 2004?
Provide a short and direct response. 1.04. What is the ratio of the Taxes (in US$) of Timor-Leste in 2001 to that in 2004?
Offer a very short reply. 0.5. What is the ratio of the Taxes (in US$) of Ukraine in 2001 to that in 2004?
Your answer should be very brief. 0.74. What is the ratio of the Taxes (in US$) of Andorra in 2001 to that in 2005?
Offer a terse response. 0.66. What is the ratio of the Taxes (in US$) in Switzerland in 2001 to that in 2005?
Ensure brevity in your answer.  1.02. What is the ratio of the Taxes (in US$) of Timor-Leste in 2001 to that in 2005?
Ensure brevity in your answer.  0.67. What is the ratio of the Taxes (in US$) of Ukraine in 2001 to that in 2005?
Keep it short and to the point. 0.45. What is the ratio of the Taxes (in US$) in Andorra in 2001 to that in 2006?
Ensure brevity in your answer.  0.66. What is the ratio of the Taxes (in US$) of Switzerland in 2001 to that in 2006?
Give a very brief answer. 0.95. What is the ratio of the Taxes (in US$) in Ukraine in 2001 to that in 2006?
Offer a terse response. 0.34. What is the ratio of the Taxes (in US$) in Andorra in 2002 to that in 2003?
Make the answer very short. 0.95. What is the ratio of the Taxes (in US$) in Switzerland in 2002 to that in 2003?
Your response must be concise. 1.01. What is the ratio of the Taxes (in US$) in Timor-Leste in 2002 to that in 2003?
Give a very brief answer. 0.8. What is the ratio of the Taxes (in US$) in Ukraine in 2002 to that in 2003?
Your answer should be very brief. 0.91. What is the ratio of the Taxes (in US$) in Andorra in 2002 to that in 2004?
Offer a terse response. 0.83. What is the ratio of the Taxes (in US$) in Switzerland in 2002 to that in 2004?
Give a very brief answer. 0.96. What is the ratio of the Taxes (in US$) of Timor-Leste in 2002 to that in 2004?
Your response must be concise. 0.75. What is the ratio of the Taxes (in US$) of Ukraine in 2002 to that in 2004?
Provide a succinct answer. 0.77. What is the ratio of the Taxes (in US$) in Andorra in 2002 to that in 2005?
Your answer should be very brief. 0.74. What is the ratio of the Taxes (in US$) of Switzerland in 2002 to that in 2005?
Your answer should be very brief. 0.94. What is the ratio of the Taxes (in US$) of Timor-Leste in 2002 to that in 2005?
Offer a very short reply. 1. What is the ratio of the Taxes (in US$) of Ukraine in 2002 to that in 2005?
Make the answer very short. 0.47. What is the ratio of the Taxes (in US$) of Andorra in 2002 to that in 2006?
Your answer should be compact. 0.74. What is the ratio of the Taxes (in US$) of Switzerland in 2002 to that in 2006?
Offer a very short reply. 0.87. What is the ratio of the Taxes (in US$) in Ukraine in 2002 to that in 2006?
Offer a very short reply. 0.35. What is the ratio of the Taxes (in US$) of Andorra in 2003 to that in 2004?
Make the answer very short. 0.87. What is the ratio of the Taxes (in US$) of Switzerland in 2003 to that in 2004?
Offer a terse response. 0.94. What is the ratio of the Taxes (in US$) of Ukraine in 2003 to that in 2004?
Make the answer very short. 0.85. What is the ratio of the Taxes (in US$) in Andorra in 2003 to that in 2005?
Keep it short and to the point. 0.78. What is the ratio of the Taxes (in US$) of Switzerland in 2003 to that in 2005?
Offer a very short reply. 0.93. What is the ratio of the Taxes (in US$) of Ukraine in 2003 to that in 2005?
Keep it short and to the point. 0.52. What is the ratio of the Taxes (in US$) of Andorra in 2003 to that in 2006?
Your answer should be compact. 0.78. What is the ratio of the Taxes (in US$) in Switzerland in 2003 to that in 2006?
Offer a terse response. 0.86. What is the ratio of the Taxes (in US$) of Ukraine in 2003 to that in 2006?
Offer a very short reply. 0.39. What is the ratio of the Taxes (in US$) in Andorra in 2004 to that in 2005?
Provide a short and direct response. 0.89. What is the ratio of the Taxes (in US$) in Switzerland in 2004 to that in 2005?
Provide a succinct answer. 0.98. What is the ratio of the Taxes (in US$) of Timor-Leste in 2004 to that in 2005?
Provide a succinct answer. 1.33. What is the ratio of the Taxes (in US$) of Ukraine in 2004 to that in 2005?
Give a very brief answer. 0.61. What is the ratio of the Taxes (in US$) in Andorra in 2004 to that in 2006?
Provide a succinct answer. 0.9. What is the ratio of the Taxes (in US$) of Switzerland in 2004 to that in 2006?
Keep it short and to the point. 0.91. What is the ratio of the Taxes (in US$) in Ukraine in 2004 to that in 2006?
Keep it short and to the point. 0.46. What is the ratio of the Taxes (in US$) in Andorra in 2005 to that in 2006?
Ensure brevity in your answer.  1.01. What is the ratio of the Taxes (in US$) in Switzerland in 2005 to that in 2006?
Provide a short and direct response. 0.93. What is the ratio of the Taxes (in US$) of Ukraine in 2005 to that in 2006?
Your answer should be very brief. 0.75. What is the difference between the highest and the second highest Taxes (in US$) of Andorra?
Ensure brevity in your answer.  1.46e+06. What is the difference between the highest and the second highest Taxes (in US$) of Switzerland?
Make the answer very short. 1.93e+08. What is the difference between the highest and the second highest Taxes (in US$) of Timor-Leste?
Your response must be concise. 1.00e+06. What is the difference between the highest and the second highest Taxes (in US$) of Ukraine?
Your answer should be compact. 1.74e+1. What is the difference between the highest and the lowest Taxes (in US$) of Andorra?
Your answer should be compact. 9.97e+07. What is the difference between the highest and the lowest Taxes (in US$) in Switzerland?
Give a very brief answer. 3.04e+09. What is the difference between the highest and the lowest Taxes (in US$) of Timor-Leste?
Your answer should be very brief. 1.60e+07. What is the difference between the highest and the lowest Taxes (in US$) of Ukraine?
Keep it short and to the point. 4.63e+1. 